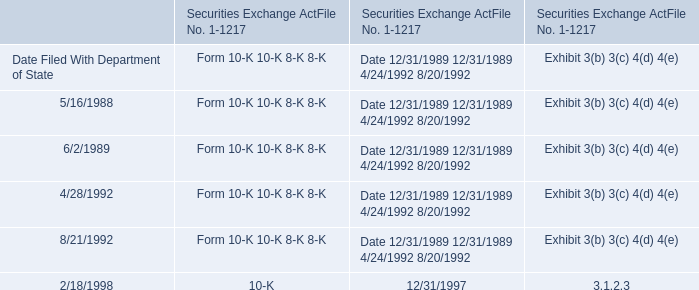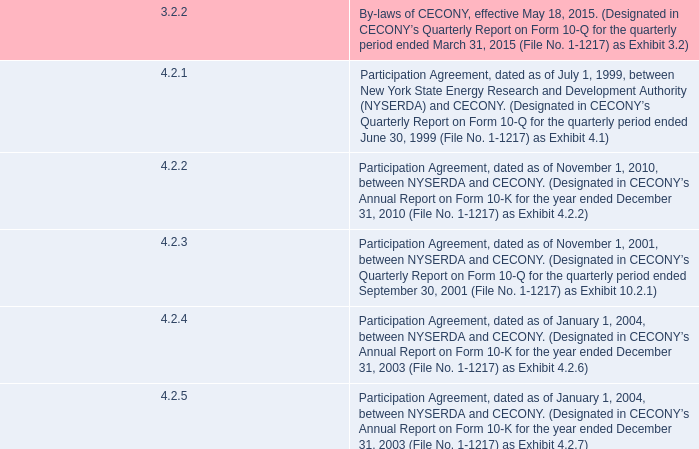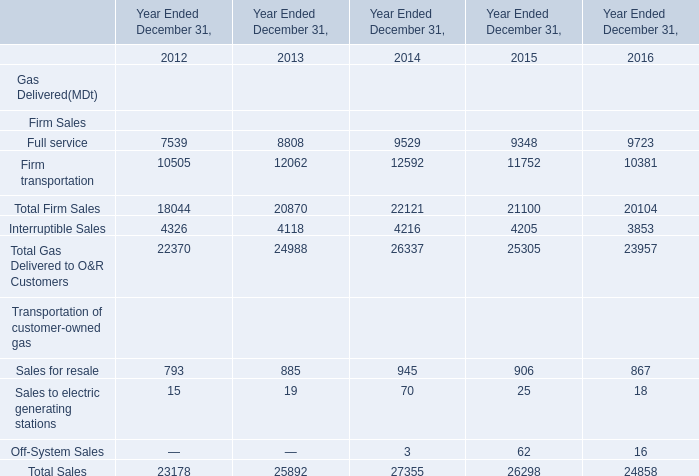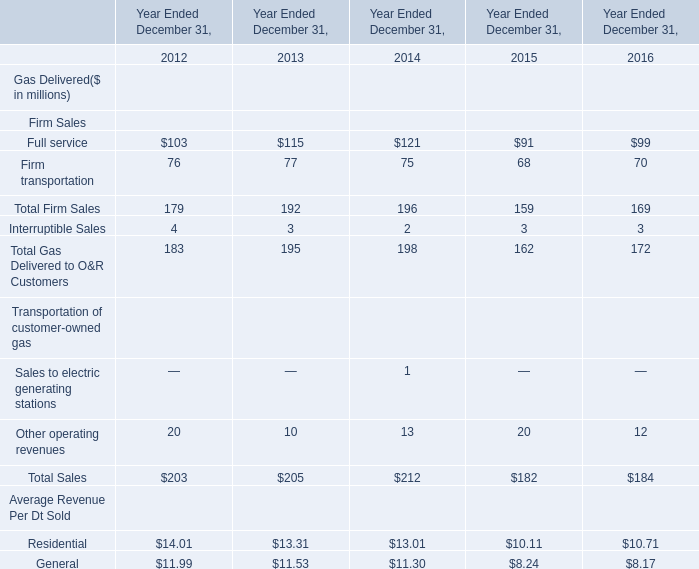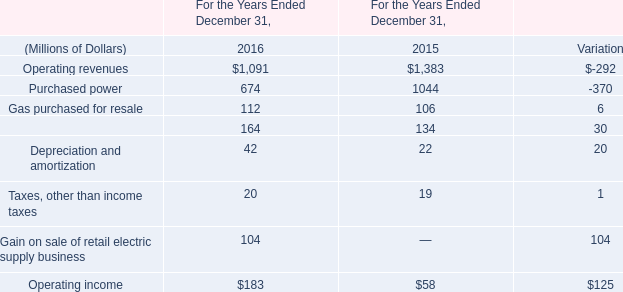What was the total amount of Other operating revenues in 2012? (in dollars in millions) 
Answer: 20. 